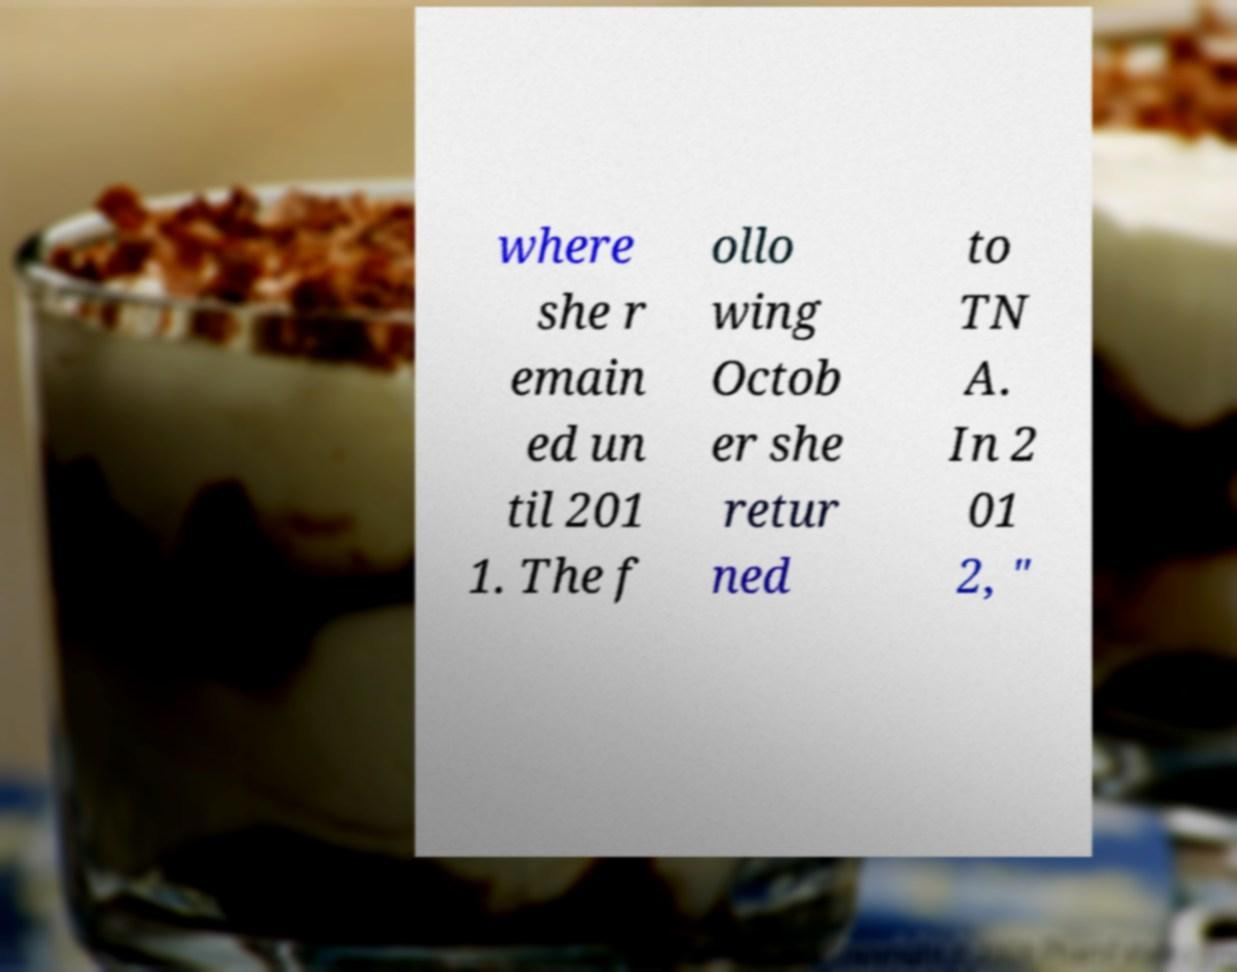For documentation purposes, I need the text within this image transcribed. Could you provide that? where she r emain ed un til 201 1. The f ollo wing Octob er she retur ned to TN A. In 2 01 2, " 